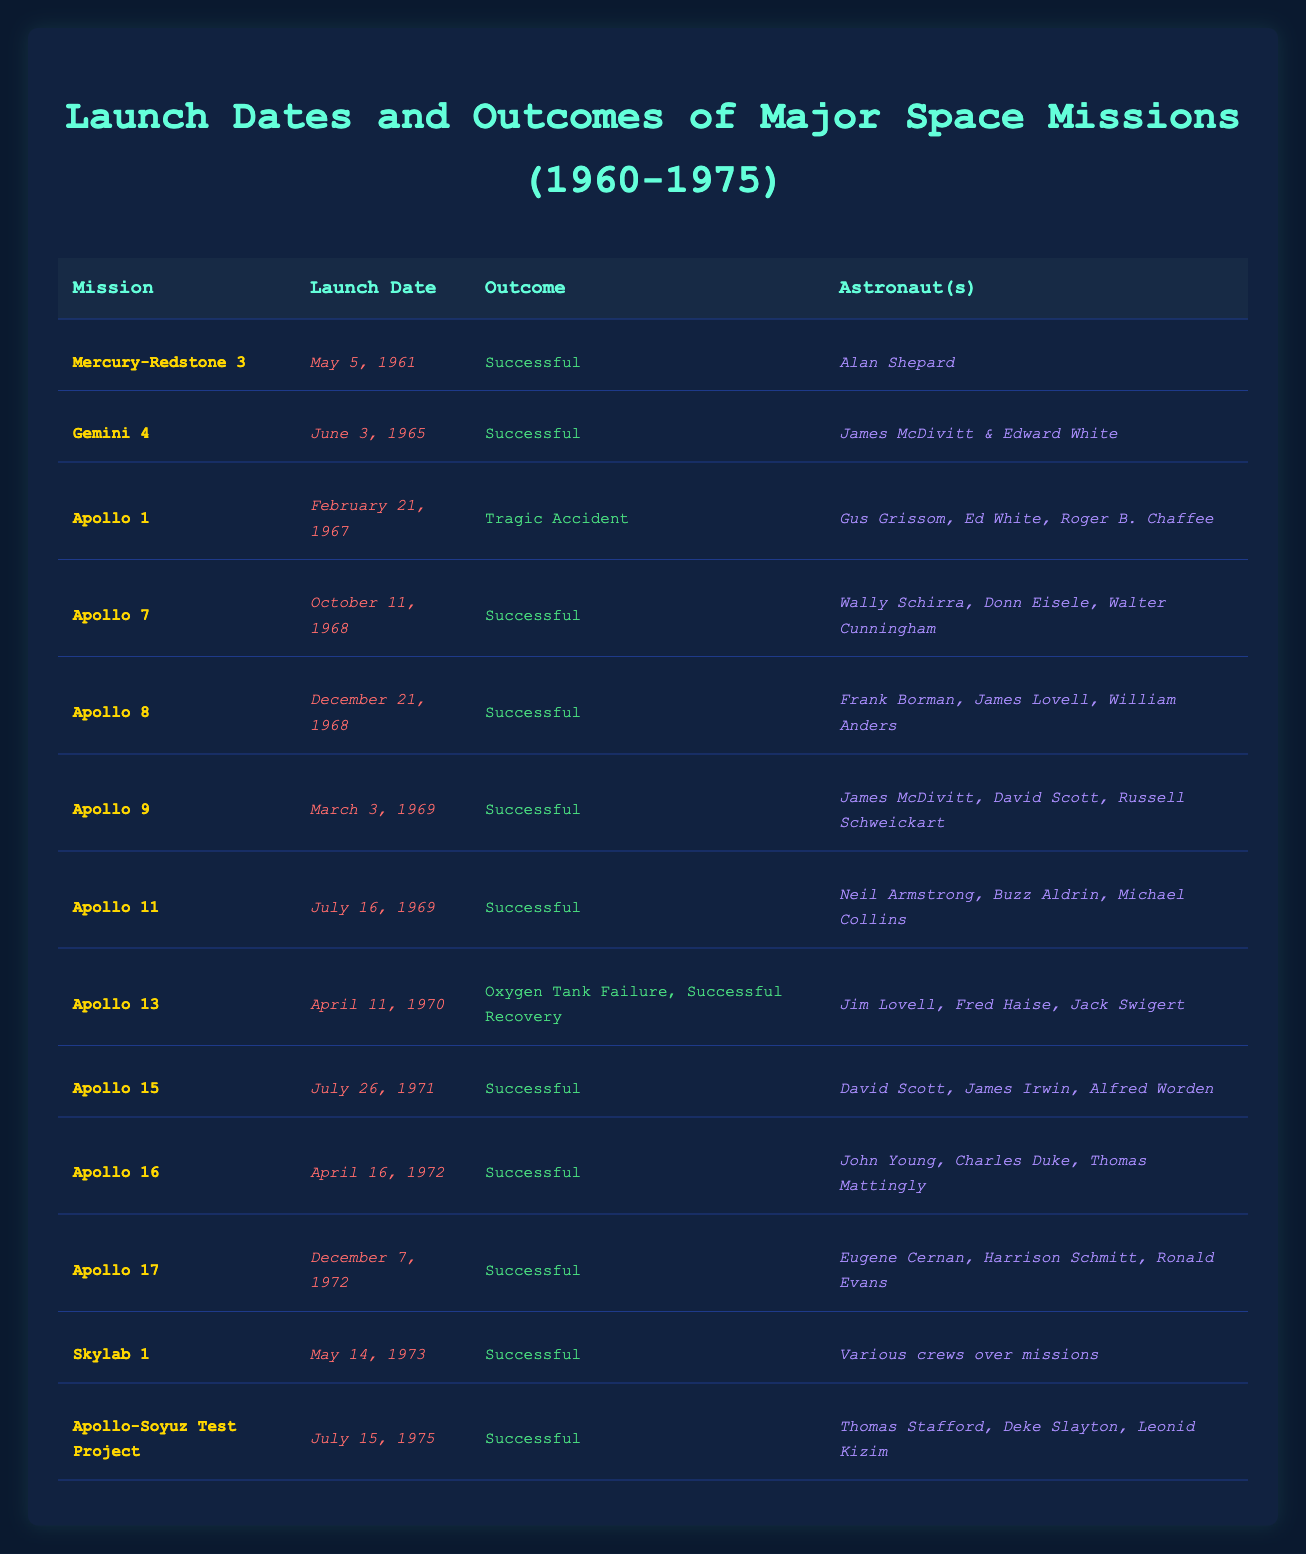What was the launch date of Apollo 11? The launch date is listed under the Apollo 11 mission in the table, which shows the date as July 16, 1969.
Answer: July 16, 1969 Which mission experienced a tragic accident? The table clearly indicates under the Apollo 1 mission that it faced a tragic accident.
Answer: Apollo 1 How many successful missions were there from this table? By counting the entries marked as "Successful," we find there are 10 successful missions (Mercury-Redstone 3, Gemini 4, Apollo 7, Apollo 8, Apollo 9, Apollo 11, Apollo 15, Apollo 16, Apollo 17, Skylab 1, Apollo-Soyuz Test Project).
Answer: 10 Did any missions take place in 1975? The table shows that the Apollo-Soyuz Test Project was launched in 1975, confirming that missions did occur in that year.
Answer: Yes What percentage of missions resulted in a successful outcome? There are 12 missions listed in total. Out of these, 10 were successful, thus calculating the percentage: (10 successful / 12 total) * 100 = 83.33%.
Answer: 83.33% Which astronaut was part of the Apollo 13 mission? The Apollo 13 mission in the table lists Jim Lovell, Fred Haise, and Jack Swigert as the astronauts involved.
Answer: Jim Lovell, Fred Haise, Jack Swigert Which mission had the longest time interval between its launch and Apollo 11's launch? We note that Apollo 11 was launched on July 16, 1969. Looking back, the longest interval before this is Mercury-Redstone 3, which launched on May 5, 1961. The difference in days is 8 years and about 2 months, or 2,194 days.
Answer: Mercury-Redstone 3 How many Apollo missions were completed before the Apollo 8 launch? The table reveals that there were five Apollo missions (Apollo 1, Apollo 7, Apollo 8) listed before the Apollo 8 launch on December 21, 1968.
Answer: 3 Was there any successful recovery after an accident in the missions? The Apollo 13's entry mentions an "Oxygen Tank Failure" but it also states "Successful Recovery," confirming that there was a successful recovery after an incident.
Answer: Yes Which astronauts were part of the Skylab 1 mission? The Skylab 1 mission in the table states "Various crews over missions," indicating that there were multiple astronauts involved but does not specify names.
Answer: Various crews over missions 